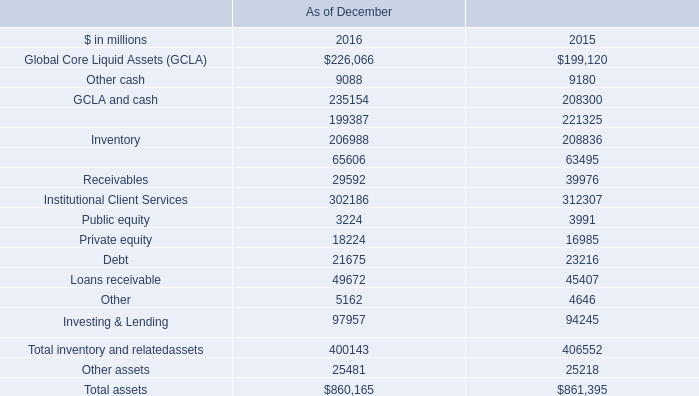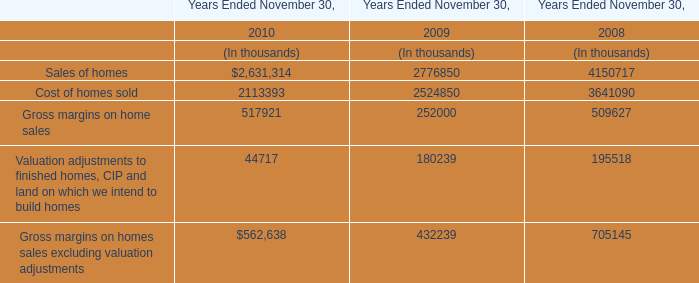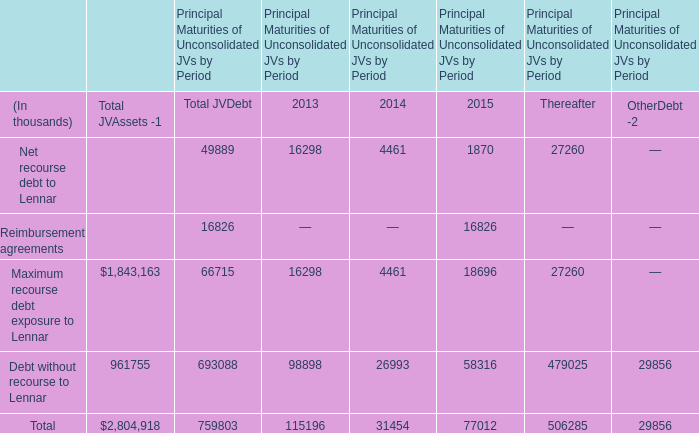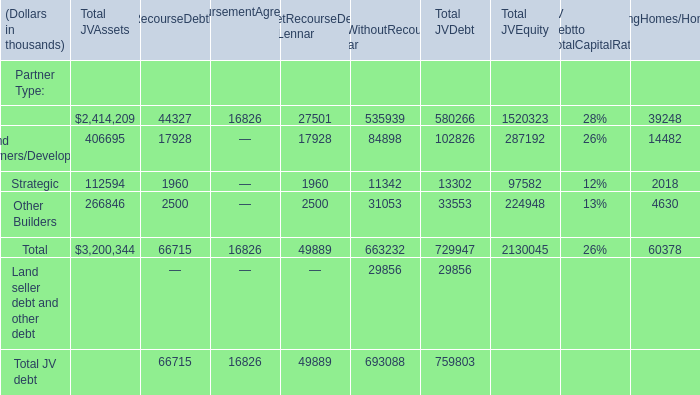What's the sum of all ReimbursementAgreements that are greater than 0 in Partner Type? (in thousand) 
Answer: 16826. 